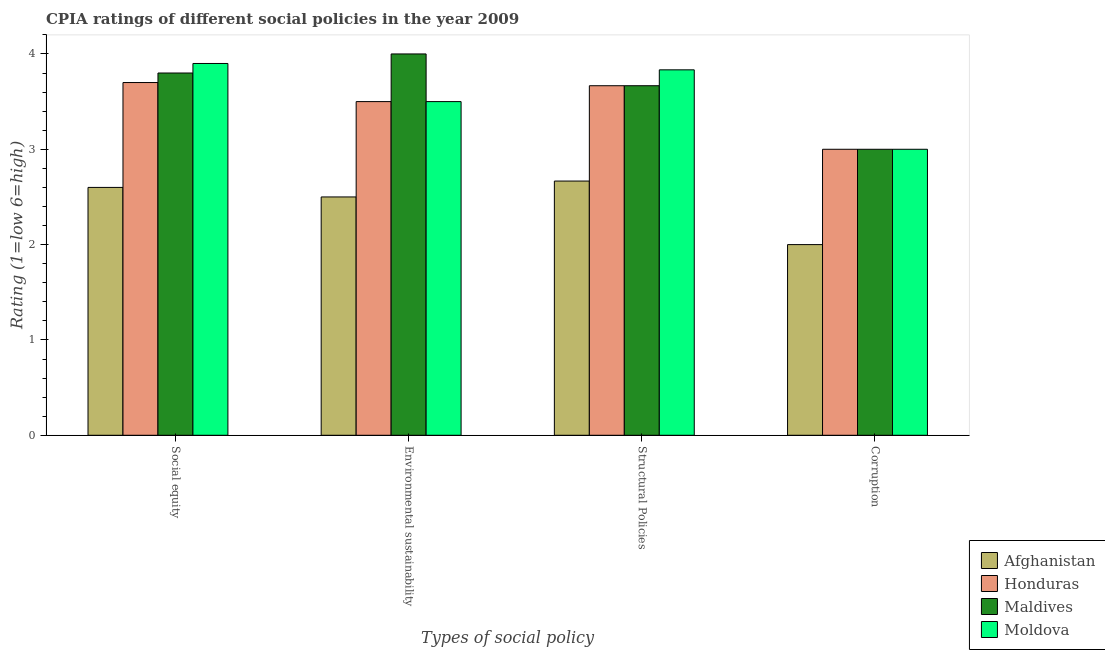Are the number of bars per tick equal to the number of legend labels?
Keep it short and to the point. Yes. Are the number of bars on each tick of the X-axis equal?
Ensure brevity in your answer.  Yes. How many bars are there on the 1st tick from the left?
Provide a succinct answer. 4. How many bars are there on the 1st tick from the right?
Your answer should be compact. 4. What is the label of the 2nd group of bars from the left?
Your response must be concise. Environmental sustainability. What is the cpia rating of structural policies in Moldova?
Ensure brevity in your answer.  3.83. Across all countries, what is the maximum cpia rating of structural policies?
Offer a terse response. 3.83. Across all countries, what is the minimum cpia rating of structural policies?
Your answer should be very brief. 2.67. In which country was the cpia rating of corruption maximum?
Offer a terse response. Honduras. In which country was the cpia rating of structural policies minimum?
Offer a terse response. Afghanistan. What is the total cpia rating of social equity in the graph?
Provide a succinct answer. 14. What is the difference between the cpia rating of social equity in Honduras and that in Moldova?
Provide a succinct answer. -0.2. What is the difference between the cpia rating of environmental sustainability in Maldives and the cpia rating of social equity in Moldova?
Your answer should be compact. 0.1. What is the average cpia rating of social equity per country?
Keep it short and to the point. 3.5. What is the difference between the cpia rating of corruption and cpia rating of structural policies in Honduras?
Your answer should be very brief. -0.67. In how many countries, is the cpia rating of environmental sustainability greater than 2.4 ?
Give a very brief answer. 4. Is the cpia rating of environmental sustainability in Moldova less than that in Maldives?
Offer a very short reply. Yes. Is the difference between the cpia rating of environmental sustainability in Moldova and Afghanistan greater than the difference between the cpia rating of structural policies in Moldova and Afghanistan?
Your response must be concise. No. What is the difference between the highest and the second highest cpia rating of environmental sustainability?
Provide a short and direct response. 0.5. In how many countries, is the cpia rating of structural policies greater than the average cpia rating of structural policies taken over all countries?
Ensure brevity in your answer.  3. Is it the case that in every country, the sum of the cpia rating of environmental sustainability and cpia rating of structural policies is greater than the sum of cpia rating of social equity and cpia rating of corruption?
Your answer should be compact. No. What does the 2nd bar from the left in Structural Policies represents?
Provide a succinct answer. Honduras. What does the 3rd bar from the right in Corruption represents?
Keep it short and to the point. Honduras. Are the values on the major ticks of Y-axis written in scientific E-notation?
Make the answer very short. No. How are the legend labels stacked?
Provide a succinct answer. Vertical. What is the title of the graph?
Keep it short and to the point. CPIA ratings of different social policies in the year 2009. What is the label or title of the X-axis?
Offer a terse response. Types of social policy. What is the Rating (1=low 6=high) of Afghanistan in Social equity?
Provide a short and direct response. 2.6. What is the Rating (1=low 6=high) of Maldives in Social equity?
Keep it short and to the point. 3.8. What is the Rating (1=low 6=high) of Moldova in Social equity?
Provide a short and direct response. 3.9. What is the Rating (1=low 6=high) of Honduras in Environmental sustainability?
Offer a very short reply. 3.5. What is the Rating (1=low 6=high) in Moldova in Environmental sustainability?
Offer a very short reply. 3.5. What is the Rating (1=low 6=high) in Afghanistan in Structural Policies?
Provide a short and direct response. 2.67. What is the Rating (1=low 6=high) in Honduras in Structural Policies?
Keep it short and to the point. 3.67. What is the Rating (1=low 6=high) in Maldives in Structural Policies?
Keep it short and to the point. 3.67. What is the Rating (1=low 6=high) of Moldova in Structural Policies?
Your answer should be very brief. 3.83. What is the Rating (1=low 6=high) in Afghanistan in Corruption?
Provide a succinct answer. 2. What is the Rating (1=low 6=high) in Honduras in Corruption?
Your answer should be very brief. 3. What is the Rating (1=low 6=high) of Maldives in Corruption?
Make the answer very short. 3. Across all Types of social policy, what is the maximum Rating (1=low 6=high) of Afghanistan?
Ensure brevity in your answer.  2.67. Across all Types of social policy, what is the maximum Rating (1=low 6=high) of Honduras?
Offer a terse response. 3.7. Across all Types of social policy, what is the maximum Rating (1=low 6=high) of Maldives?
Your response must be concise. 4. Across all Types of social policy, what is the maximum Rating (1=low 6=high) in Moldova?
Provide a succinct answer. 3.9. Across all Types of social policy, what is the minimum Rating (1=low 6=high) in Afghanistan?
Ensure brevity in your answer.  2. What is the total Rating (1=low 6=high) of Afghanistan in the graph?
Your answer should be very brief. 9.77. What is the total Rating (1=low 6=high) in Honduras in the graph?
Keep it short and to the point. 13.87. What is the total Rating (1=low 6=high) of Maldives in the graph?
Your answer should be compact. 14.47. What is the total Rating (1=low 6=high) in Moldova in the graph?
Your answer should be compact. 14.23. What is the difference between the Rating (1=low 6=high) of Afghanistan in Social equity and that in Environmental sustainability?
Your response must be concise. 0.1. What is the difference between the Rating (1=low 6=high) in Afghanistan in Social equity and that in Structural Policies?
Your answer should be very brief. -0.07. What is the difference between the Rating (1=low 6=high) of Maldives in Social equity and that in Structural Policies?
Offer a terse response. 0.13. What is the difference between the Rating (1=low 6=high) in Moldova in Social equity and that in Structural Policies?
Provide a succinct answer. 0.07. What is the difference between the Rating (1=low 6=high) in Afghanistan in Social equity and that in Corruption?
Keep it short and to the point. 0.6. What is the difference between the Rating (1=low 6=high) in Honduras in Social equity and that in Corruption?
Ensure brevity in your answer.  0.7. What is the difference between the Rating (1=low 6=high) of Afghanistan in Environmental sustainability and that in Structural Policies?
Offer a terse response. -0.17. What is the difference between the Rating (1=low 6=high) of Honduras in Environmental sustainability and that in Structural Policies?
Give a very brief answer. -0.17. What is the difference between the Rating (1=low 6=high) of Moldova in Environmental sustainability and that in Structural Policies?
Offer a terse response. -0.33. What is the difference between the Rating (1=low 6=high) of Afghanistan in Environmental sustainability and that in Corruption?
Provide a succinct answer. 0.5. What is the difference between the Rating (1=low 6=high) of Maldives in Environmental sustainability and that in Corruption?
Give a very brief answer. 1. What is the difference between the Rating (1=low 6=high) in Moldova in Environmental sustainability and that in Corruption?
Provide a short and direct response. 0.5. What is the difference between the Rating (1=low 6=high) in Honduras in Structural Policies and that in Corruption?
Offer a very short reply. 0.67. What is the difference between the Rating (1=low 6=high) of Moldova in Structural Policies and that in Corruption?
Offer a terse response. 0.83. What is the difference between the Rating (1=low 6=high) of Afghanistan in Social equity and the Rating (1=low 6=high) of Moldova in Environmental sustainability?
Provide a short and direct response. -0.9. What is the difference between the Rating (1=low 6=high) in Honduras in Social equity and the Rating (1=low 6=high) in Maldives in Environmental sustainability?
Provide a short and direct response. -0.3. What is the difference between the Rating (1=low 6=high) in Honduras in Social equity and the Rating (1=low 6=high) in Moldova in Environmental sustainability?
Your answer should be compact. 0.2. What is the difference between the Rating (1=low 6=high) in Afghanistan in Social equity and the Rating (1=low 6=high) in Honduras in Structural Policies?
Give a very brief answer. -1.07. What is the difference between the Rating (1=low 6=high) in Afghanistan in Social equity and the Rating (1=low 6=high) in Maldives in Structural Policies?
Give a very brief answer. -1.07. What is the difference between the Rating (1=low 6=high) in Afghanistan in Social equity and the Rating (1=low 6=high) in Moldova in Structural Policies?
Provide a succinct answer. -1.23. What is the difference between the Rating (1=low 6=high) of Honduras in Social equity and the Rating (1=low 6=high) of Moldova in Structural Policies?
Provide a succinct answer. -0.13. What is the difference between the Rating (1=low 6=high) of Maldives in Social equity and the Rating (1=low 6=high) of Moldova in Structural Policies?
Make the answer very short. -0.03. What is the difference between the Rating (1=low 6=high) in Afghanistan in Social equity and the Rating (1=low 6=high) in Maldives in Corruption?
Give a very brief answer. -0.4. What is the difference between the Rating (1=low 6=high) in Afghanistan in Social equity and the Rating (1=low 6=high) in Moldova in Corruption?
Offer a terse response. -0.4. What is the difference between the Rating (1=low 6=high) of Honduras in Social equity and the Rating (1=low 6=high) of Moldova in Corruption?
Give a very brief answer. 0.7. What is the difference between the Rating (1=low 6=high) of Afghanistan in Environmental sustainability and the Rating (1=low 6=high) of Honduras in Structural Policies?
Offer a very short reply. -1.17. What is the difference between the Rating (1=low 6=high) in Afghanistan in Environmental sustainability and the Rating (1=low 6=high) in Maldives in Structural Policies?
Give a very brief answer. -1.17. What is the difference between the Rating (1=low 6=high) in Afghanistan in Environmental sustainability and the Rating (1=low 6=high) in Moldova in Structural Policies?
Provide a short and direct response. -1.33. What is the difference between the Rating (1=low 6=high) of Afghanistan in Environmental sustainability and the Rating (1=low 6=high) of Maldives in Corruption?
Offer a terse response. -0.5. What is the difference between the Rating (1=low 6=high) of Maldives in Environmental sustainability and the Rating (1=low 6=high) of Moldova in Corruption?
Ensure brevity in your answer.  1. What is the difference between the Rating (1=low 6=high) of Afghanistan in Structural Policies and the Rating (1=low 6=high) of Maldives in Corruption?
Make the answer very short. -0.33. What is the average Rating (1=low 6=high) of Afghanistan per Types of social policy?
Ensure brevity in your answer.  2.44. What is the average Rating (1=low 6=high) in Honduras per Types of social policy?
Your response must be concise. 3.47. What is the average Rating (1=low 6=high) in Maldives per Types of social policy?
Your answer should be compact. 3.62. What is the average Rating (1=low 6=high) in Moldova per Types of social policy?
Keep it short and to the point. 3.56. What is the difference between the Rating (1=low 6=high) of Honduras and Rating (1=low 6=high) of Maldives in Social equity?
Provide a short and direct response. -0.1. What is the difference between the Rating (1=low 6=high) of Honduras and Rating (1=low 6=high) of Moldova in Social equity?
Provide a short and direct response. -0.2. What is the difference between the Rating (1=low 6=high) of Afghanistan and Rating (1=low 6=high) of Moldova in Environmental sustainability?
Ensure brevity in your answer.  -1. What is the difference between the Rating (1=low 6=high) in Honduras and Rating (1=low 6=high) in Maldives in Environmental sustainability?
Make the answer very short. -0.5. What is the difference between the Rating (1=low 6=high) in Honduras and Rating (1=low 6=high) in Moldova in Environmental sustainability?
Your answer should be very brief. 0. What is the difference between the Rating (1=low 6=high) in Afghanistan and Rating (1=low 6=high) in Maldives in Structural Policies?
Your response must be concise. -1. What is the difference between the Rating (1=low 6=high) in Afghanistan and Rating (1=low 6=high) in Moldova in Structural Policies?
Offer a terse response. -1.17. What is the difference between the Rating (1=low 6=high) in Honduras and Rating (1=low 6=high) in Maldives in Structural Policies?
Offer a terse response. 0. What is the difference between the Rating (1=low 6=high) of Honduras and Rating (1=low 6=high) of Moldova in Structural Policies?
Offer a very short reply. -0.17. What is the difference between the Rating (1=low 6=high) in Afghanistan and Rating (1=low 6=high) in Honduras in Corruption?
Offer a terse response. -1. What is the difference between the Rating (1=low 6=high) in Afghanistan and Rating (1=low 6=high) in Moldova in Corruption?
Provide a succinct answer. -1. What is the difference between the Rating (1=low 6=high) in Maldives and Rating (1=low 6=high) in Moldova in Corruption?
Ensure brevity in your answer.  0. What is the ratio of the Rating (1=low 6=high) in Afghanistan in Social equity to that in Environmental sustainability?
Your response must be concise. 1.04. What is the ratio of the Rating (1=low 6=high) in Honduras in Social equity to that in Environmental sustainability?
Your response must be concise. 1.06. What is the ratio of the Rating (1=low 6=high) of Maldives in Social equity to that in Environmental sustainability?
Give a very brief answer. 0.95. What is the ratio of the Rating (1=low 6=high) of Moldova in Social equity to that in Environmental sustainability?
Your response must be concise. 1.11. What is the ratio of the Rating (1=low 6=high) of Honduras in Social equity to that in Structural Policies?
Ensure brevity in your answer.  1.01. What is the ratio of the Rating (1=low 6=high) in Maldives in Social equity to that in Structural Policies?
Your answer should be very brief. 1.04. What is the ratio of the Rating (1=low 6=high) in Moldova in Social equity to that in Structural Policies?
Keep it short and to the point. 1.02. What is the ratio of the Rating (1=low 6=high) of Honduras in Social equity to that in Corruption?
Offer a very short reply. 1.23. What is the ratio of the Rating (1=low 6=high) of Maldives in Social equity to that in Corruption?
Ensure brevity in your answer.  1.27. What is the ratio of the Rating (1=low 6=high) of Honduras in Environmental sustainability to that in Structural Policies?
Your answer should be compact. 0.95. What is the ratio of the Rating (1=low 6=high) in Maldives in Environmental sustainability to that in Structural Policies?
Your answer should be compact. 1.09. What is the ratio of the Rating (1=low 6=high) of Moldova in Environmental sustainability to that in Structural Policies?
Make the answer very short. 0.91. What is the ratio of the Rating (1=low 6=high) in Afghanistan in Environmental sustainability to that in Corruption?
Your answer should be compact. 1.25. What is the ratio of the Rating (1=low 6=high) of Honduras in Structural Policies to that in Corruption?
Make the answer very short. 1.22. What is the ratio of the Rating (1=low 6=high) of Maldives in Structural Policies to that in Corruption?
Make the answer very short. 1.22. What is the ratio of the Rating (1=low 6=high) of Moldova in Structural Policies to that in Corruption?
Offer a terse response. 1.28. What is the difference between the highest and the second highest Rating (1=low 6=high) of Afghanistan?
Keep it short and to the point. 0.07. What is the difference between the highest and the second highest Rating (1=low 6=high) in Honduras?
Your response must be concise. 0.03. What is the difference between the highest and the second highest Rating (1=low 6=high) in Moldova?
Keep it short and to the point. 0.07. What is the difference between the highest and the lowest Rating (1=low 6=high) of Maldives?
Offer a terse response. 1. 